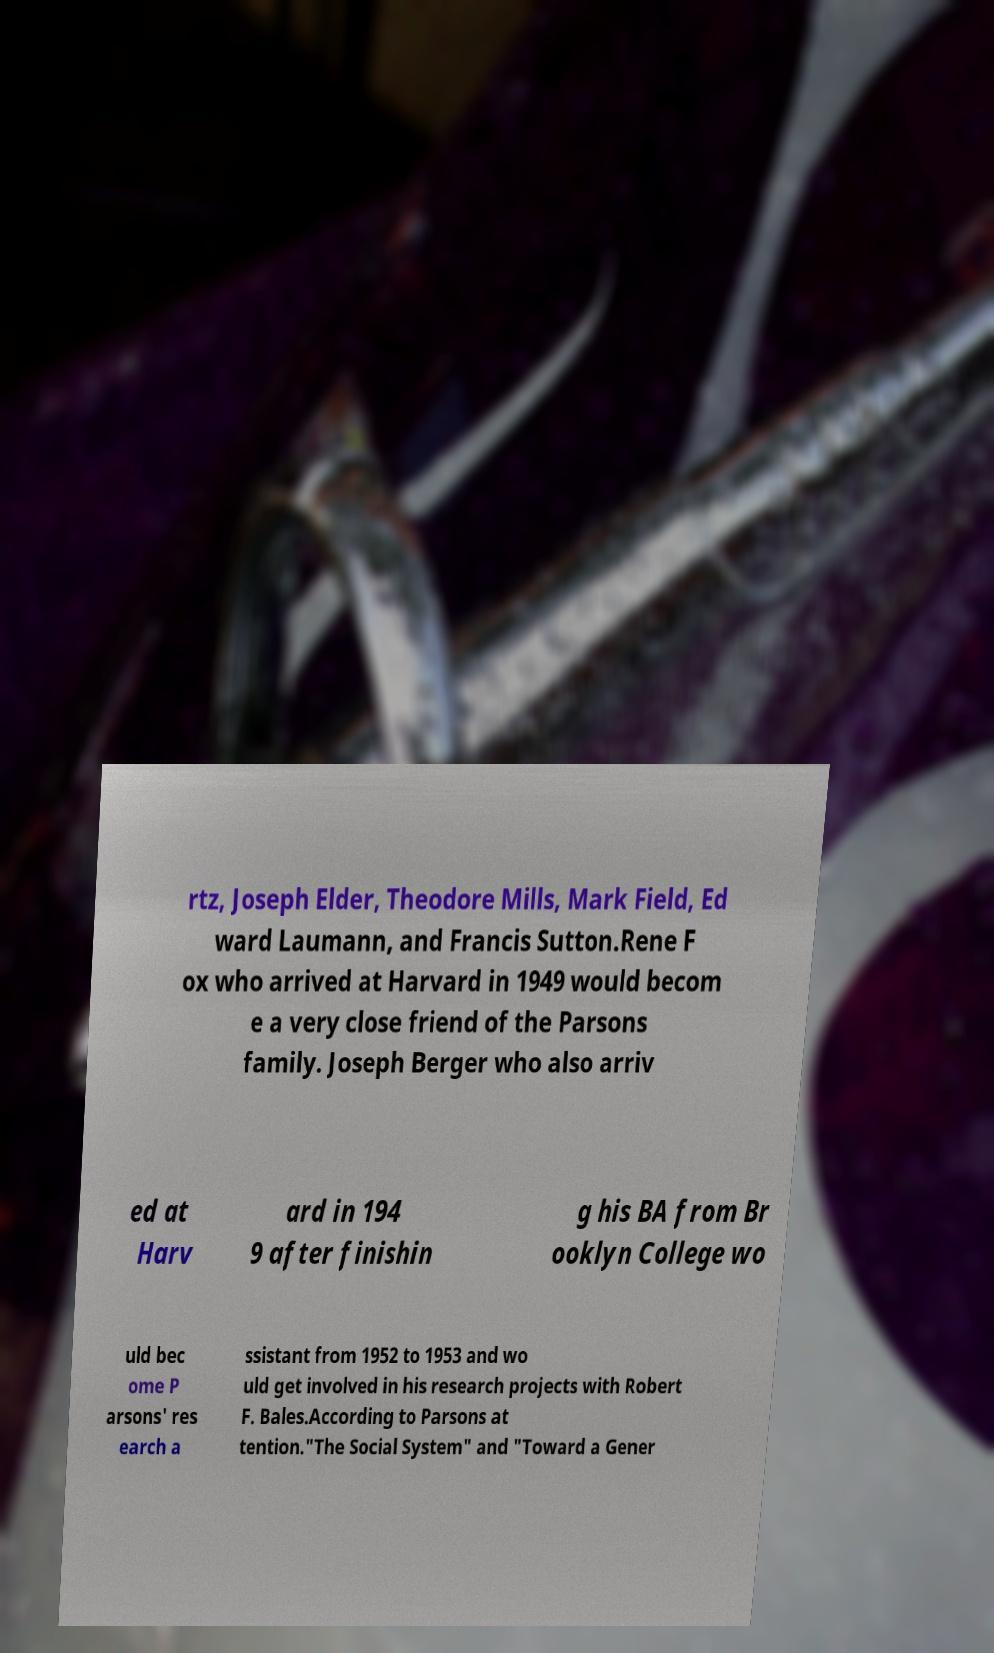For documentation purposes, I need the text within this image transcribed. Could you provide that? rtz, Joseph Elder, Theodore Mills, Mark Field, Ed ward Laumann, and Francis Sutton.Rene F ox who arrived at Harvard in 1949 would becom e a very close friend of the Parsons family. Joseph Berger who also arriv ed at Harv ard in 194 9 after finishin g his BA from Br ooklyn College wo uld bec ome P arsons' res earch a ssistant from 1952 to 1953 and wo uld get involved in his research projects with Robert F. Bales.According to Parsons at tention."The Social System" and "Toward a Gener 